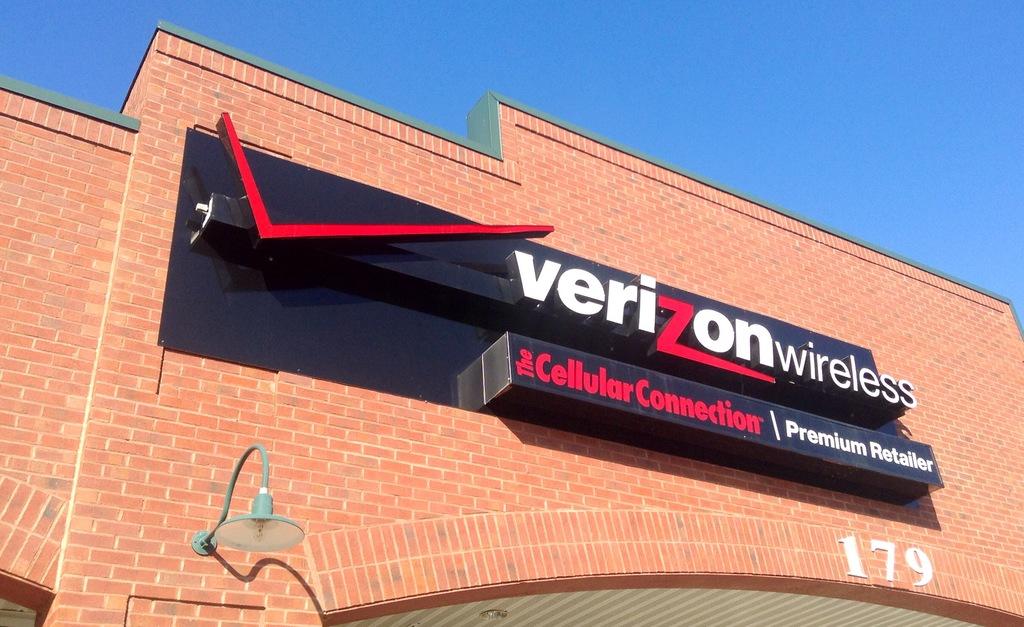What brand of cell phone store is it?
Make the answer very short. Verizon. 